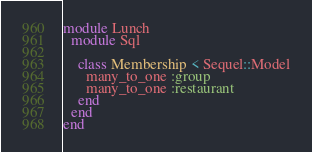<code> <loc_0><loc_0><loc_500><loc_500><_Ruby_>module Lunch
  module Sql

    class Membership < Sequel::Model
      many_to_one :group
      many_to_one :restaurant      
    end        
  end
end
</code> 